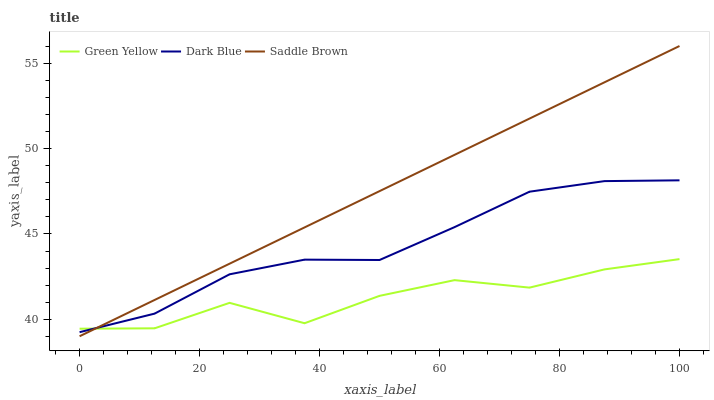Does Green Yellow have the minimum area under the curve?
Answer yes or no. Yes. Does Saddle Brown have the maximum area under the curve?
Answer yes or no. Yes. Does Saddle Brown have the minimum area under the curve?
Answer yes or no. No. Does Green Yellow have the maximum area under the curve?
Answer yes or no. No. Is Saddle Brown the smoothest?
Answer yes or no. Yes. Is Green Yellow the roughest?
Answer yes or no. Yes. Is Green Yellow the smoothest?
Answer yes or no. No. Is Saddle Brown the roughest?
Answer yes or no. No. Does Saddle Brown have the lowest value?
Answer yes or no. Yes. Does Green Yellow have the lowest value?
Answer yes or no. No. Does Saddle Brown have the highest value?
Answer yes or no. Yes. Does Green Yellow have the highest value?
Answer yes or no. No. Does Dark Blue intersect Green Yellow?
Answer yes or no. Yes. Is Dark Blue less than Green Yellow?
Answer yes or no. No. Is Dark Blue greater than Green Yellow?
Answer yes or no. No. 